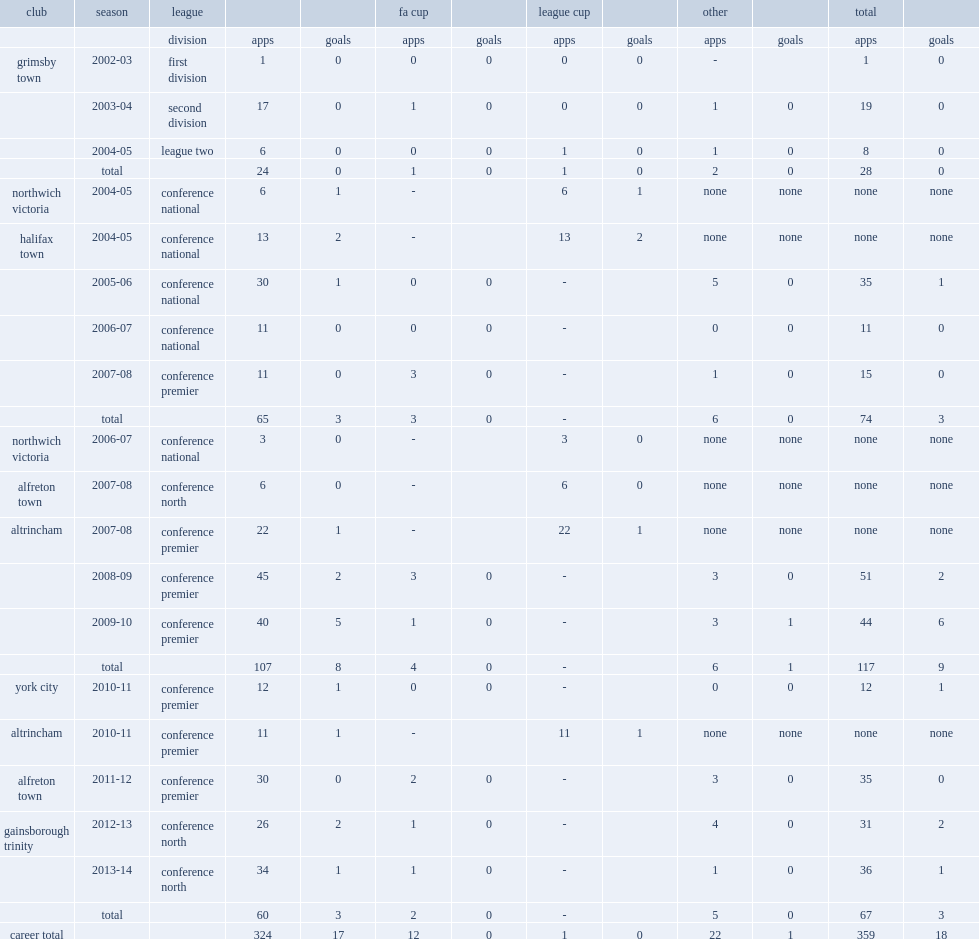Which league did young sign for club gainsborough trinity in the 2012-13 season? Conference north. Parse the table in full. {'header': ['club', 'season', 'league', '', '', 'fa cup', '', 'league cup', '', 'other', '', 'total', ''], 'rows': [['', '', 'division', 'apps', 'goals', 'apps', 'goals', 'apps', 'goals', 'apps', 'goals', 'apps', 'goals'], ['grimsby town', '2002-03', 'first division', '1', '0', '0', '0', '0', '0', '-', '', '1', '0'], ['', '2003-04', 'second division', '17', '0', '1', '0', '0', '0', '1', '0', '19', '0'], ['', '2004-05', 'league two', '6', '0', '0', '0', '1', '0', '1', '0', '8', '0'], ['', 'total', '', '24', '0', '1', '0', '1', '0', '2', '0', '28', '0'], ['northwich victoria', '2004-05', 'conference national', '6', '1', '-', '', '6', '1', 'none', 'none', 'none', 'none'], ['halifax town', '2004-05', 'conference national', '13', '2', '-', '', '13', '2', 'none', 'none', 'none', 'none'], ['', '2005-06', 'conference national', '30', '1', '0', '0', '-', '', '5', '0', '35', '1'], ['', '2006-07', 'conference national', '11', '0', '0', '0', '-', '', '0', '0', '11', '0'], ['', '2007-08', 'conference premier', '11', '0', '3', '0', '-', '', '1', '0', '15', '0'], ['', 'total', '', '65', '3', '3', '0', '-', '', '6', '0', '74', '3'], ['northwich victoria', '2006-07', 'conference national', '3', '0', '-', '', '3', '0', 'none', 'none', 'none', 'none'], ['alfreton town', '2007-08', 'conference north', '6', '0', '-', '', '6', '0', 'none', 'none', 'none', 'none'], ['altrincham', '2007-08', 'conference premier', '22', '1', '-', '', '22', '1', 'none', 'none', 'none', 'none'], ['', '2008-09', 'conference premier', '45', '2', '3', '0', '-', '', '3', '0', '51', '2'], ['', '2009-10', 'conference premier', '40', '5', '1', '0', '-', '', '3', '1', '44', '6'], ['', 'total', '', '107', '8', '4', '0', '-', '', '6', '1', '117', '9'], ['york city', '2010-11', 'conference premier', '12', '1', '0', '0', '-', '', '0', '0', '12', '1'], ['altrincham', '2010-11', 'conference premier', '11', '1', '-', '', '11', '1', 'none', 'none', 'none', 'none'], ['alfreton town', '2011-12', 'conference premier', '30', '0', '2', '0', '-', '', '3', '0', '35', '0'], ['gainsborough trinity', '2012-13', 'conference north', '26', '2', '1', '0', '-', '', '4', '0', '31', '2'], ['', '2013-14', 'conference north', '34', '1', '1', '0', '-', '', '1', '0', '36', '1'], ['', 'total', '', '60', '3', '2', '0', '-', '', '5', '0', '67', '3'], ['career total', '', '', '324', '17', '12', '0', '1', '0', '22', '1', '359', '18']]} 